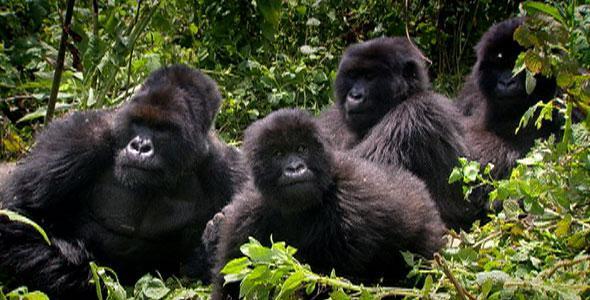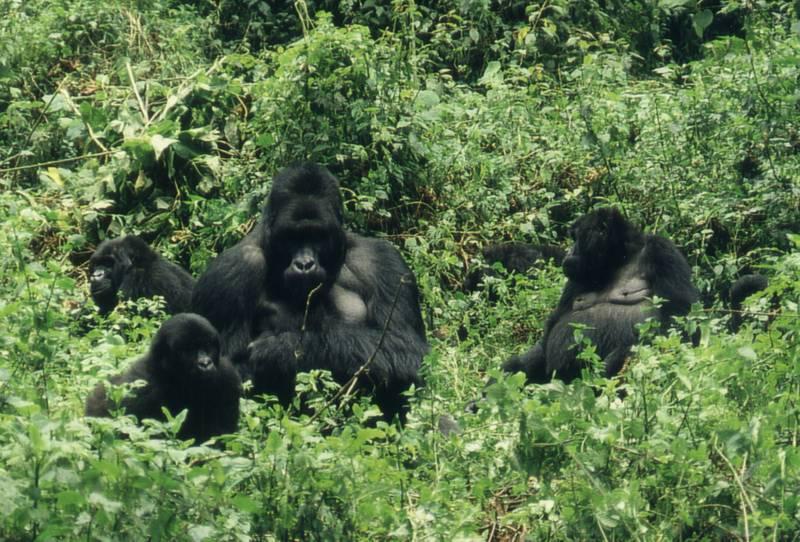The first image is the image on the left, the second image is the image on the right. Assess this claim about the two images: "On one image, a baby gorilla is perched on a bigger gorilla.". Correct or not? Answer yes or no. No. The first image is the image on the left, the second image is the image on the right. For the images displayed, is the sentence "One image contains at least three times the number of apes as the other image." factually correct? Answer yes or no. No. 